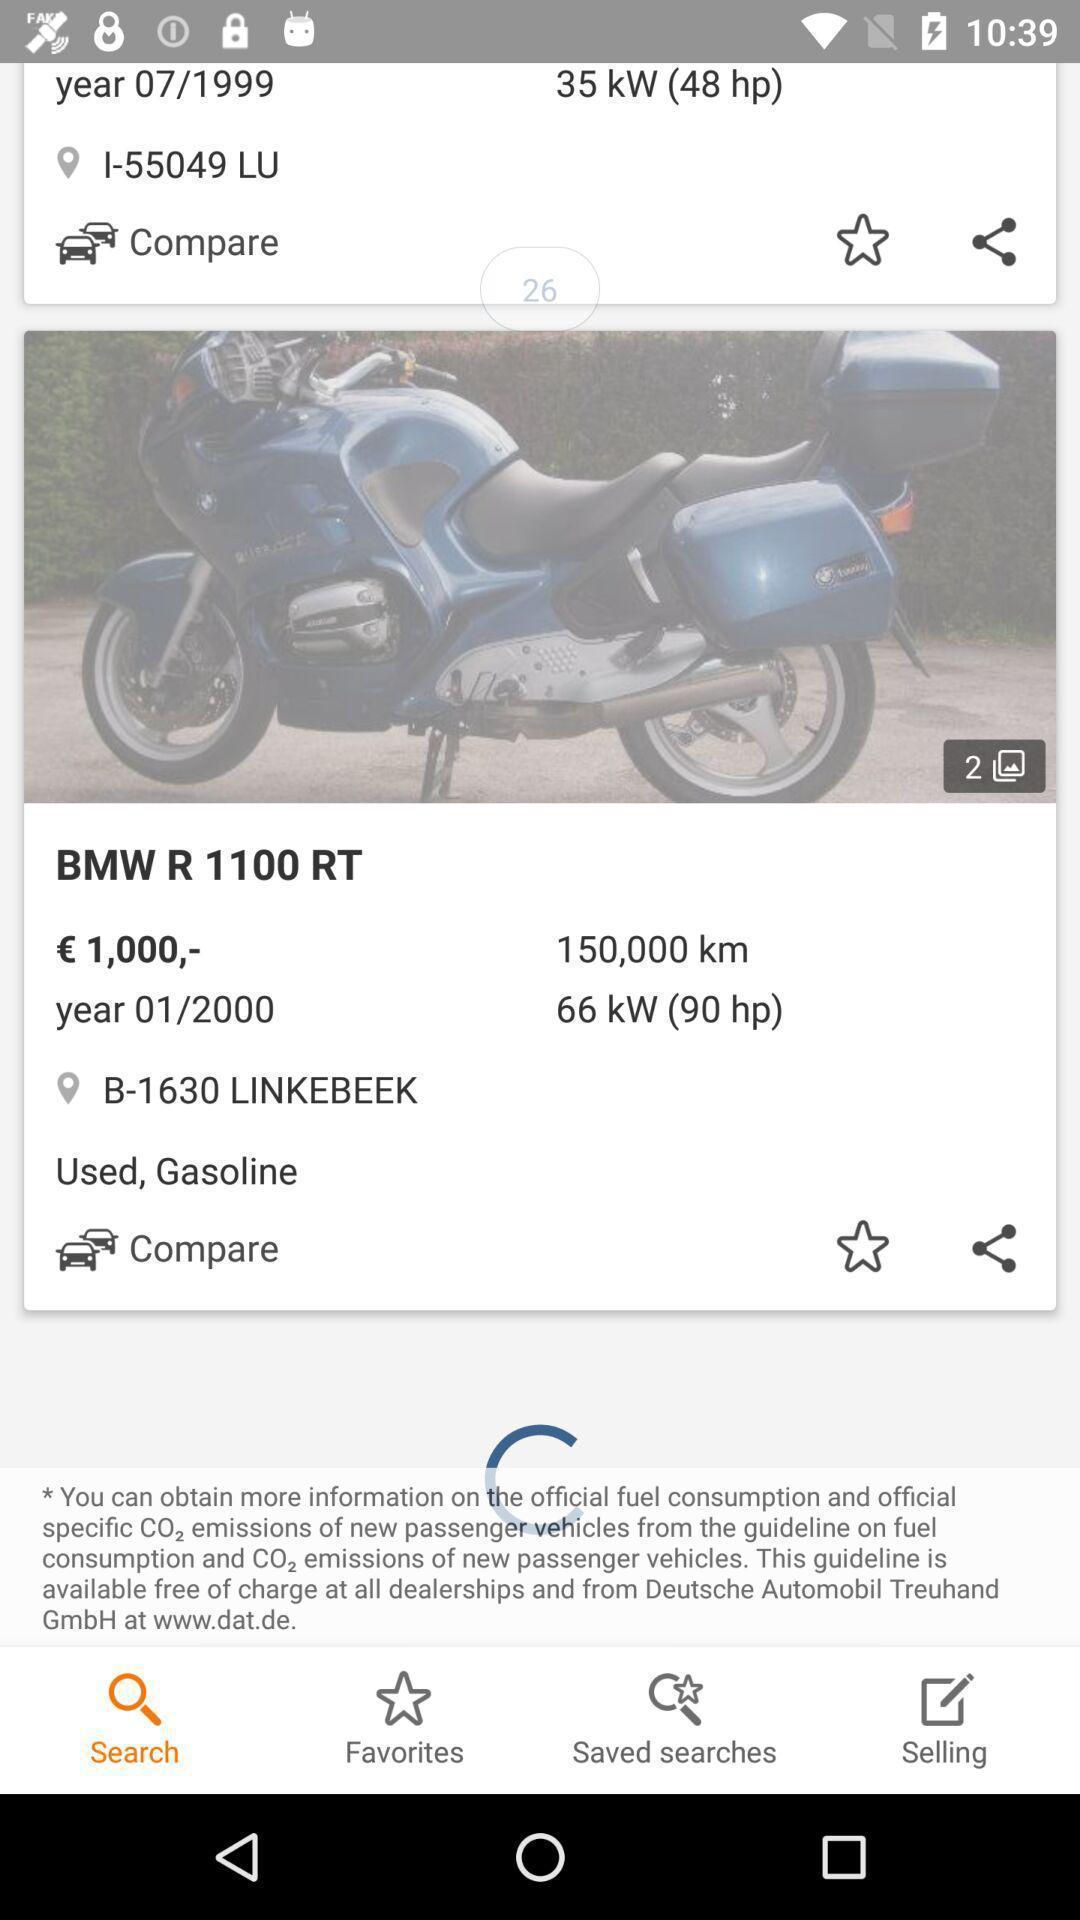Describe the key features of this screenshot. Result page of a searched bike details. 